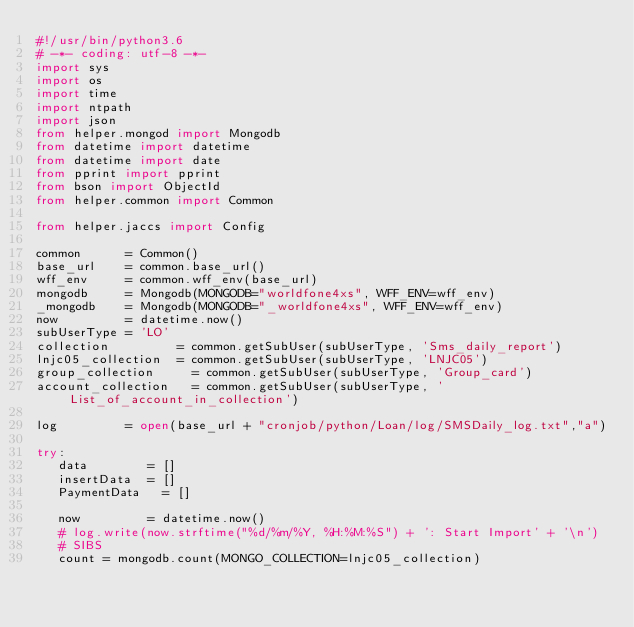Convert code to text. <code><loc_0><loc_0><loc_500><loc_500><_Python_>#!/usr/bin/python3.6
# -*- coding: utf-8 -*-
import sys
import os
import time
import ntpath
import json
from helper.mongod import Mongodb
from datetime import datetime
from datetime import date
from pprint import pprint
from bson import ObjectId
from helper.common import Common

from helper.jaccs import Config

common      = Common()
base_url    = common.base_url()
wff_env     = common.wff_env(base_url)
mongodb     = Mongodb(MONGODB="worldfone4xs", WFF_ENV=wff_env)
_mongodb    = Mongodb(MONGODB="_worldfone4xs", WFF_ENV=wff_env)
now         = datetime.now()
subUserType = 'LO'
collection         = common.getSubUser(subUserType, 'Sms_daily_report')
lnjc05_collection  = common.getSubUser(subUserType, 'LNJC05')
group_collection     = common.getSubUser(subUserType, 'Group_card')
account_collection   = common.getSubUser(subUserType, 'List_of_account_in_collection')

log         = open(base_url + "cronjob/python/Loan/log/SMSDaily_log.txt","a")

try:
   data        = []
   insertData  = []
   PaymentData   = []

   now         = datetime.now()
   # log.write(now.strftime("%d/%m/%Y, %H:%M:%S") + ': Start Import' + '\n')
   # SIBS
   count = mongodb.count(MONGO_COLLECTION=lnjc05_collection)</code> 